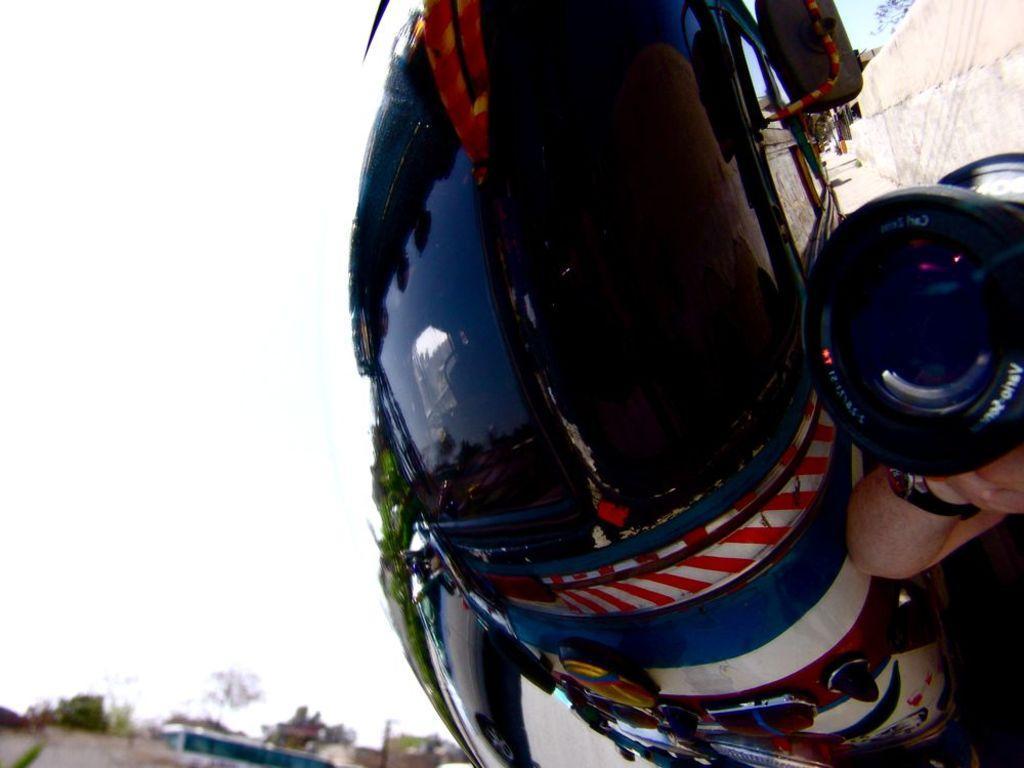Please provide a concise description of this image. This is an edited image. I can see a bus and a car on the road. On the left side of the image, I can see a wall and a person's hand holding a camera. At the bottom of the image, there are trees and a building. In the background, there is the sky. 